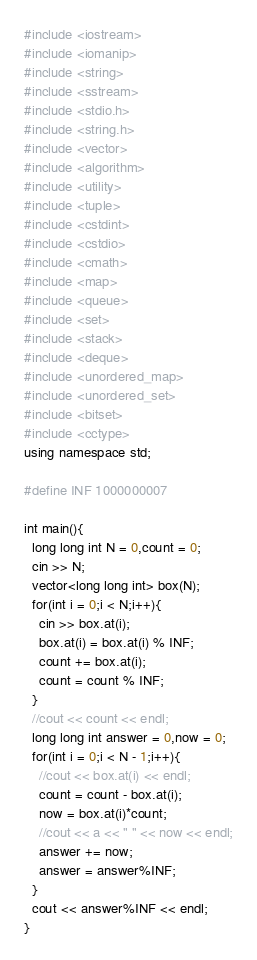<code> <loc_0><loc_0><loc_500><loc_500><_C++_>#include <iostream>
#include <iomanip>
#include <string>
#include <sstream>
#include <stdio.h>
#include <string.h>
#include <vector>
#include <algorithm>
#include <utility>
#include <tuple>
#include <cstdint>
#include <cstdio>
#include <cmath>
#include <map>
#include <queue>
#include <set>
#include <stack>
#include <deque>
#include <unordered_map>
#include <unordered_set>
#include <bitset>
#include <cctype>
using namespace std;

#define INF 1000000007

int main(){
  long long int N = 0,count = 0;
  cin >> N;
  vector<long long int> box(N);
  for(int i = 0;i < N;i++){
    cin >> box.at(i);
    box.at(i) = box.at(i) % INF;
    count += box.at(i);
    count = count % INF;
  }
  //cout << count << endl;
  long long int answer = 0,now = 0;
  for(int i = 0;i < N - 1;i++){
    //cout << box.at(i) << endl;
    count = count - box.at(i);
    now = box.at(i)*count;
    //cout << a << " " << now << endl;
    answer += now;
    answer = answer%INF;
  }
  cout << answer%INF << endl;
}
</code> 